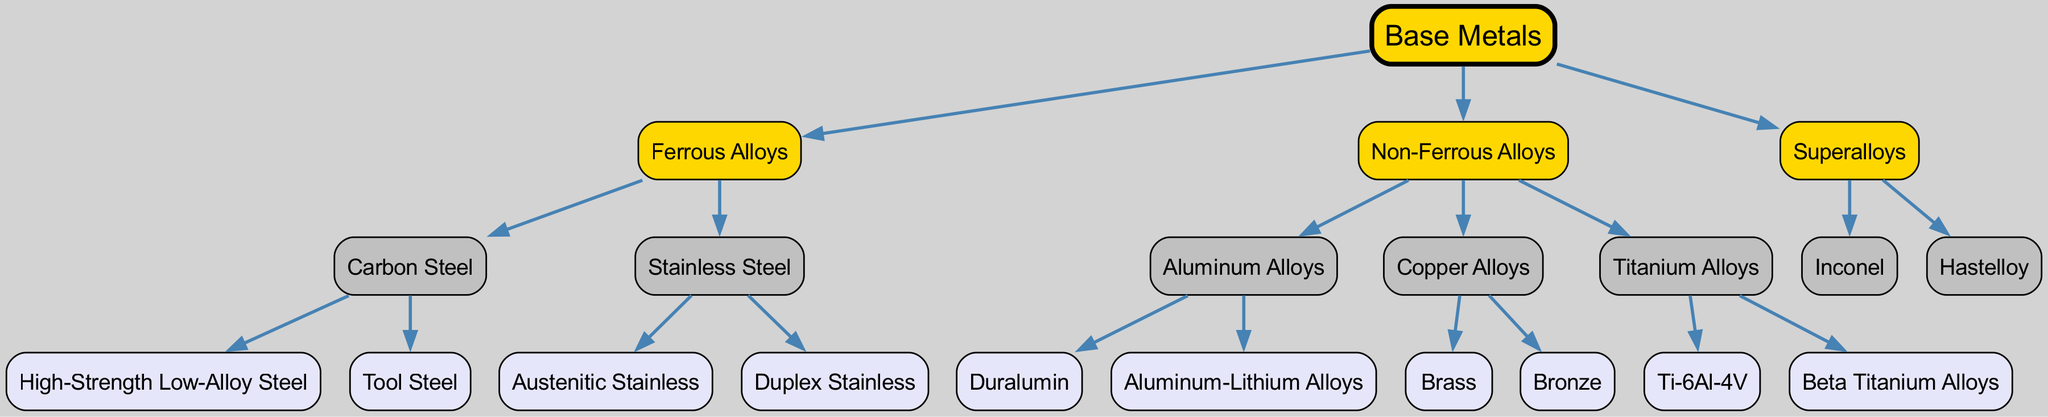What is the root of the family tree? The root node of the family tree represents the starting point, which in this case is labeled as "Base Metals".
Answer: Base Metals How many main categories are there under Base Metals? There are three main categories directly under the root "Base Metals": "Ferrous Alloys", "Non-Ferrous Alloys", and "Superalloys".
Answer: 3 Which alloy type belongs to the Ferrous Alloys category? The diagram indicates that "Carbon Steel" and "Stainless Steel" are the two children of the "Ferrous Alloys" category.
Answer: Carbon Steel Name a subtype of Aluminum Alloys. The section for "Aluminum Alloys" shows two children, one of which is "Duralumin". Thus, "Duralumin" is a subtype.
Answer: Duralumin What is the total number of subtypes for Non-Ferrous Alloys? Non-Ferrous Alloys have three subcategories: "Aluminum Alloys", "Copper Alloys", and "Titanium Alloys", each with their own respective subtypes, making a total of five subtypes when fully counted.
Answer: 5 Which two types are classified under Stainless Steel? The diagram provides information that "Austenitic Stainless" and "Duplex Stainless" are the children of "Stainless Steel".
Answer: Austenitic Stainless, Duplex Stainless What color represents the root node in the diagram? In the family tree diagram, the root node "Base Metals" is colored gold (#FFD700).
Answer: Gold Which alloy belongs to the Superalloys category? The children of "Superalloys" are "Inconel" and "Hastelloy", so both are classified in this category.
Answer: Inconel, Hastelloy What is the relationship between Carbon Steel and Ferrous Alloys? "Carbon Steel" is a subtype or child of the "Ferrous Alloys" category, meaning it falls under this main classification of ferrous materials.
Answer: Child 